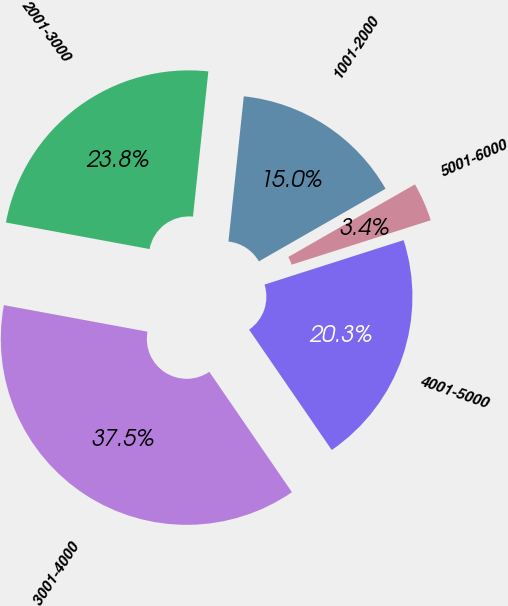Convert chart. <chart><loc_0><loc_0><loc_500><loc_500><pie_chart><fcel>1001-2000<fcel>2001-3000<fcel>3001-4000<fcel>4001-5000<fcel>5001-6000<nl><fcel>15.04%<fcel>23.77%<fcel>37.49%<fcel>20.35%<fcel>3.36%<nl></chart> 